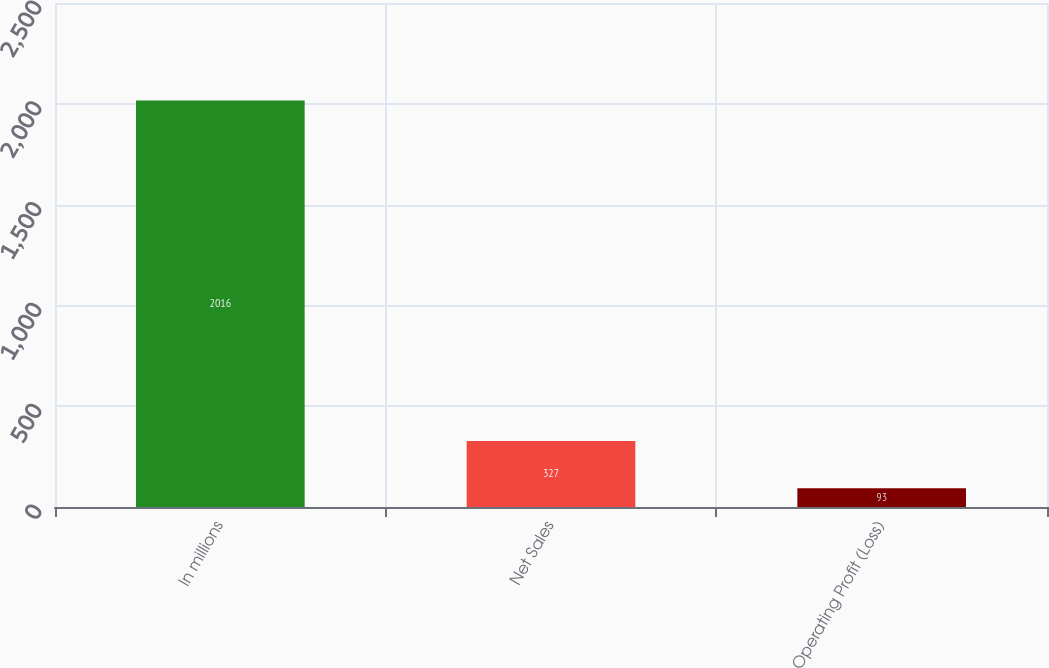Convert chart. <chart><loc_0><loc_0><loc_500><loc_500><bar_chart><fcel>In millions<fcel>Net Sales<fcel>Operating Profit (Loss)<nl><fcel>2016<fcel>327<fcel>93<nl></chart> 